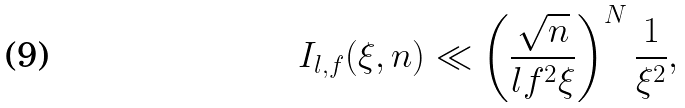Convert formula to latex. <formula><loc_0><loc_0><loc_500><loc_500>I _ { l , f } ( \xi , n ) \ll \left ( \frac { \sqrt { n } } { l f ^ { 2 } \xi } \right ) ^ { N } \frac { 1 } { \xi ^ { 2 } } ,</formula> 